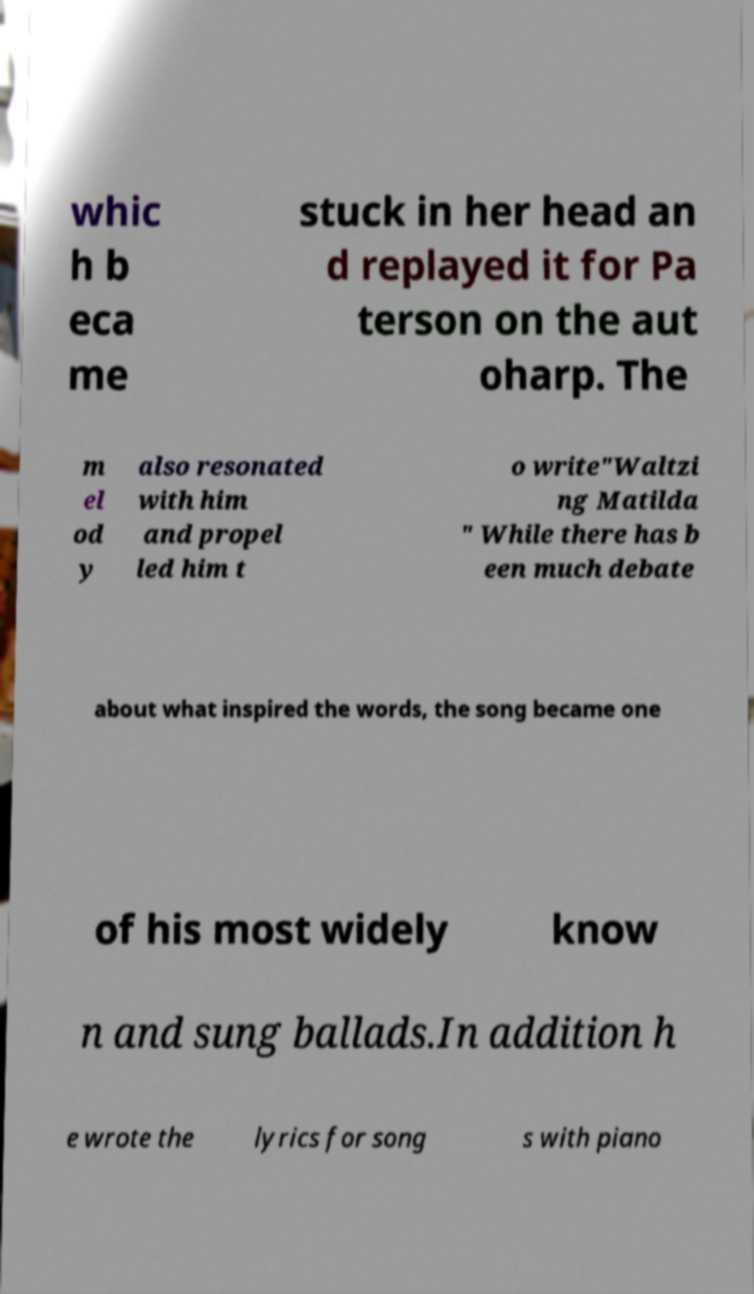Could you assist in decoding the text presented in this image and type it out clearly? whic h b eca me stuck in her head an d replayed it for Pa terson on the aut oharp. The m el od y also resonated with him and propel led him t o write"Waltzi ng Matilda " While there has b een much debate about what inspired the words, the song became one of his most widely know n and sung ballads.In addition h e wrote the lyrics for song s with piano 